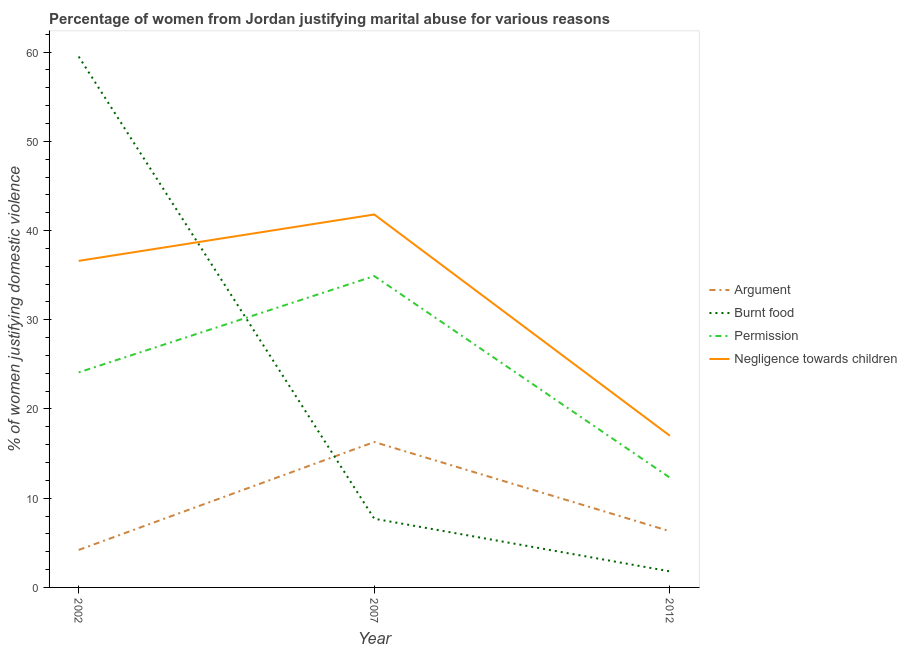How many different coloured lines are there?
Make the answer very short. 4. Across all years, what is the maximum percentage of women justifying abuse for showing negligence towards children?
Make the answer very short. 41.8. Across all years, what is the minimum percentage of women justifying abuse in the case of an argument?
Your response must be concise. 4.2. What is the difference between the percentage of women justifying abuse for going without permission in 2002 and that in 2012?
Offer a terse response. 11.8. What is the difference between the percentage of women justifying abuse for going without permission in 2002 and the percentage of women justifying abuse in the case of an argument in 2007?
Offer a terse response. 7.8. What is the average percentage of women justifying abuse for going without permission per year?
Keep it short and to the point. 23.77. In the year 2007, what is the difference between the percentage of women justifying abuse in the case of an argument and percentage of women justifying abuse for going without permission?
Provide a succinct answer. -18.6. In how many years, is the percentage of women justifying abuse in the case of an argument greater than 52 %?
Your answer should be compact. 0. What is the ratio of the percentage of women justifying abuse in the case of an argument in 2002 to that in 2012?
Give a very brief answer. 0.67. Is the percentage of women justifying abuse in the case of an argument in 2007 less than that in 2012?
Ensure brevity in your answer.  No. What is the difference between the highest and the second highest percentage of women justifying abuse for going without permission?
Your response must be concise. 10.8. What is the difference between the highest and the lowest percentage of women justifying abuse for burning food?
Provide a succinct answer. 57.7. In how many years, is the percentage of women justifying abuse in the case of an argument greater than the average percentage of women justifying abuse in the case of an argument taken over all years?
Provide a short and direct response. 1. Is the sum of the percentage of women justifying abuse for showing negligence towards children in 2002 and 2012 greater than the maximum percentage of women justifying abuse in the case of an argument across all years?
Provide a short and direct response. Yes. Is it the case that in every year, the sum of the percentage of women justifying abuse in the case of an argument and percentage of women justifying abuse for burning food is greater than the percentage of women justifying abuse for going without permission?
Provide a short and direct response. No. Is the percentage of women justifying abuse for going without permission strictly less than the percentage of women justifying abuse for burning food over the years?
Keep it short and to the point. No. How many years are there in the graph?
Your response must be concise. 3. Does the graph contain any zero values?
Make the answer very short. No. Does the graph contain grids?
Give a very brief answer. No. Where does the legend appear in the graph?
Make the answer very short. Center right. How many legend labels are there?
Keep it short and to the point. 4. What is the title of the graph?
Your response must be concise. Percentage of women from Jordan justifying marital abuse for various reasons. What is the label or title of the Y-axis?
Offer a very short reply. % of women justifying domestic violence. What is the % of women justifying domestic violence in Argument in 2002?
Your response must be concise. 4.2. What is the % of women justifying domestic violence in Burnt food in 2002?
Your answer should be very brief. 59.5. What is the % of women justifying domestic violence in Permission in 2002?
Your answer should be compact. 24.1. What is the % of women justifying domestic violence of Negligence towards children in 2002?
Provide a short and direct response. 36.6. What is the % of women justifying domestic violence in Argument in 2007?
Provide a succinct answer. 16.3. What is the % of women justifying domestic violence in Permission in 2007?
Provide a succinct answer. 34.9. What is the % of women justifying domestic violence in Negligence towards children in 2007?
Give a very brief answer. 41.8. Across all years, what is the maximum % of women justifying domestic violence in Burnt food?
Ensure brevity in your answer.  59.5. Across all years, what is the maximum % of women justifying domestic violence in Permission?
Your answer should be very brief. 34.9. Across all years, what is the maximum % of women justifying domestic violence of Negligence towards children?
Your response must be concise. 41.8. Across all years, what is the minimum % of women justifying domestic violence in Argument?
Offer a very short reply. 4.2. Across all years, what is the minimum % of women justifying domestic violence in Burnt food?
Provide a succinct answer. 1.8. What is the total % of women justifying domestic violence of Argument in the graph?
Offer a very short reply. 26.8. What is the total % of women justifying domestic violence of Permission in the graph?
Provide a succinct answer. 71.3. What is the total % of women justifying domestic violence of Negligence towards children in the graph?
Offer a terse response. 95.4. What is the difference between the % of women justifying domestic violence in Argument in 2002 and that in 2007?
Offer a terse response. -12.1. What is the difference between the % of women justifying domestic violence of Burnt food in 2002 and that in 2007?
Provide a short and direct response. 51.8. What is the difference between the % of women justifying domestic violence in Permission in 2002 and that in 2007?
Provide a succinct answer. -10.8. What is the difference between the % of women justifying domestic violence of Argument in 2002 and that in 2012?
Ensure brevity in your answer.  -2.1. What is the difference between the % of women justifying domestic violence of Burnt food in 2002 and that in 2012?
Keep it short and to the point. 57.7. What is the difference between the % of women justifying domestic violence in Negligence towards children in 2002 and that in 2012?
Offer a terse response. 19.6. What is the difference between the % of women justifying domestic violence of Permission in 2007 and that in 2012?
Your answer should be compact. 22.6. What is the difference between the % of women justifying domestic violence in Negligence towards children in 2007 and that in 2012?
Make the answer very short. 24.8. What is the difference between the % of women justifying domestic violence in Argument in 2002 and the % of women justifying domestic violence in Permission in 2007?
Offer a very short reply. -30.7. What is the difference between the % of women justifying domestic violence of Argument in 2002 and the % of women justifying domestic violence of Negligence towards children in 2007?
Your answer should be compact. -37.6. What is the difference between the % of women justifying domestic violence of Burnt food in 2002 and the % of women justifying domestic violence of Permission in 2007?
Ensure brevity in your answer.  24.6. What is the difference between the % of women justifying domestic violence in Burnt food in 2002 and the % of women justifying domestic violence in Negligence towards children in 2007?
Your answer should be compact. 17.7. What is the difference between the % of women justifying domestic violence of Permission in 2002 and the % of women justifying domestic violence of Negligence towards children in 2007?
Make the answer very short. -17.7. What is the difference between the % of women justifying domestic violence in Argument in 2002 and the % of women justifying domestic violence in Burnt food in 2012?
Your response must be concise. 2.4. What is the difference between the % of women justifying domestic violence in Argument in 2002 and the % of women justifying domestic violence in Negligence towards children in 2012?
Provide a succinct answer. -12.8. What is the difference between the % of women justifying domestic violence in Burnt food in 2002 and the % of women justifying domestic violence in Permission in 2012?
Provide a short and direct response. 47.2. What is the difference between the % of women justifying domestic violence in Burnt food in 2002 and the % of women justifying domestic violence in Negligence towards children in 2012?
Your answer should be compact. 42.5. What is the difference between the % of women justifying domestic violence of Argument in 2007 and the % of women justifying domestic violence of Permission in 2012?
Offer a terse response. 4. What is the difference between the % of women justifying domestic violence in Burnt food in 2007 and the % of women justifying domestic violence in Permission in 2012?
Provide a short and direct response. -4.6. What is the difference between the % of women justifying domestic violence of Permission in 2007 and the % of women justifying domestic violence of Negligence towards children in 2012?
Keep it short and to the point. 17.9. What is the average % of women justifying domestic violence in Argument per year?
Your answer should be very brief. 8.93. What is the average % of women justifying domestic violence in Burnt food per year?
Keep it short and to the point. 23. What is the average % of women justifying domestic violence of Permission per year?
Make the answer very short. 23.77. What is the average % of women justifying domestic violence in Negligence towards children per year?
Your response must be concise. 31.8. In the year 2002, what is the difference between the % of women justifying domestic violence of Argument and % of women justifying domestic violence of Burnt food?
Make the answer very short. -55.3. In the year 2002, what is the difference between the % of women justifying domestic violence of Argument and % of women justifying domestic violence of Permission?
Ensure brevity in your answer.  -19.9. In the year 2002, what is the difference between the % of women justifying domestic violence in Argument and % of women justifying domestic violence in Negligence towards children?
Offer a very short reply. -32.4. In the year 2002, what is the difference between the % of women justifying domestic violence in Burnt food and % of women justifying domestic violence in Permission?
Provide a short and direct response. 35.4. In the year 2002, what is the difference between the % of women justifying domestic violence of Burnt food and % of women justifying domestic violence of Negligence towards children?
Offer a very short reply. 22.9. In the year 2007, what is the difference between the % of women justifying domestic violence in Argument and % of women justifying domestic violence in Burnt food?
Your answer should be compact. 8.6. In the year 2007, what is the difference between the % of women justifying domestic violence in Argument and % of women justifying domestic violence in Permission?
Your answer should be very brief. -18.6. In the year 2007, what is the difference between the % of women justifying domestic violence of Argument and % of women justifying domestic violence of Negligence towards children?
Offer a very short reply. -25.5. In the year 2007, what is the difference between the % of women justifying domestic violence of Burnt food and % of women justifying domestic violence of Permission?
Provide a short and direct response. -27.2. In the year 2007, what is the difference between the % of women justifying domestic violence of Burnt food and % of women justifying domestic violence of Negligence towards children?
Give a very brief answer. -34.1. In the year 2012, what is the difference between the % of women justifying domestic violence of Argument and % of women justifying domestic violence of Burnt food?
Provide a succinct answer. 4.5. In the year 2012, what is the difference between the % of women justifying domestic violence of Argument and % of women justifying domestic violence of Negligence towards children?
Your response must be concise. -10.7. In the year 2012, what is the difference between the % of women justifying domestic violence in Burnt food and % of women justifying domestic violence in Negligence towards children?
Give a very brief answer. -15.2. In the year 2012, what is the difference between the % of women justifying domestic violence of Permission and % of women justifying domestic violence of Negligence towards children?
Provide a short and direct response. -4.7. What is the ratio of the % of women justifying domestic violence in Argument in 2002 to that in 2007?
Give a very brief answer. 0.26. What is the ratio of the % of women justifying domestic violence of Burnt food in 2002 to that in 2007?
Give a very brief answer. 7.73. What is the ratio of the % of women justifying domestic violence of Permission in 2002 to that in 2007?
Make the answer very short. 0.69. What is the ratio of the % of women justifying domestic violence of Negligence towards children in 2002 to that in 2007?
Give a very brief answer. 0.88. What is the ratio of the % of women justifying domestic violence in Burnt food in 2002 to that in 2012?
Offer a terse response. 33.06. What is the ratio of the % of women justifying domestic violence of Permission in 2002 to that in 2012?
Your response must be concise. 1.96. What is the ratio of the % of women justifying domestic violence of Negligence towards children in 2002 to that in 2012?
Your answer should be compact. 2.15. What is the ratio of the % of women justifying domestic violence in Argument in 2007 to that in 2012?
Make the answer very short. 2.59. What is the ratio of the % of women justifying domestic violence of Burnt food in 2007 to that in 2012?
Provide a succinct answer. 4.28. What is the ratio of the % of women justifying domestic violence of Permission in 2007 to that in 2012?
Offer a very short reply. 2.84. What is the ratio of the % of women justifying domestic violence in Negligence towards children in 2007 to that in 2012?
Offer a terse response. 2.46. What is the difference between the highest and the second highest % of women justifying domestic violence in Argument?
Provide a succinct answer. 10. What is the difference between the highest and the second highest % of women justifying domestic violence in Burnt food?
Ensure brevity in your answer.  51.8. What is the difference between the highest and the second highest % of women justifying domestic violence in Permission?
Give a very brief answer. 10.8. What is the difference between the highest and the second highest % of women justifying domestic violence in Negligence towards children?
Ensure brevity in your answer.  5.2. What is the difference between the highest and the lowest % of women justifying domestic violence of Burnt food?
Provide a succinct answer. 57.7. What is the difference between the highest and the lowest % of women justifying domestic violence of Permission?
Provide a succinct answer. 22.6. What is the difference between the highest and the lowest % of women justifying domestic violence in Negligence towards children?
Your answer should be compact. 24.8. 